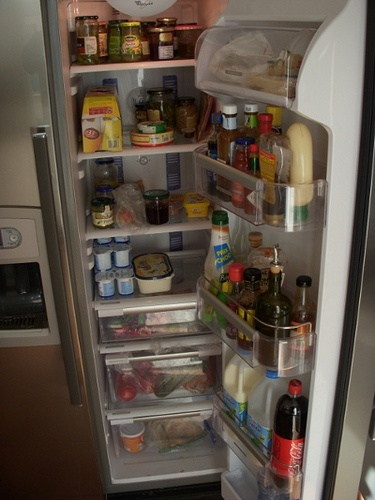Describe the objects in this image and their specific colors. I can see refrigerator in gray, black, darkgray, and maroon tones, bottle in gray, black, and maroon tones, bottle in gray, black, maroon, and brown tones, bottle in gray and black tones, and bottle in gray, blue, and navy tones in this image. 